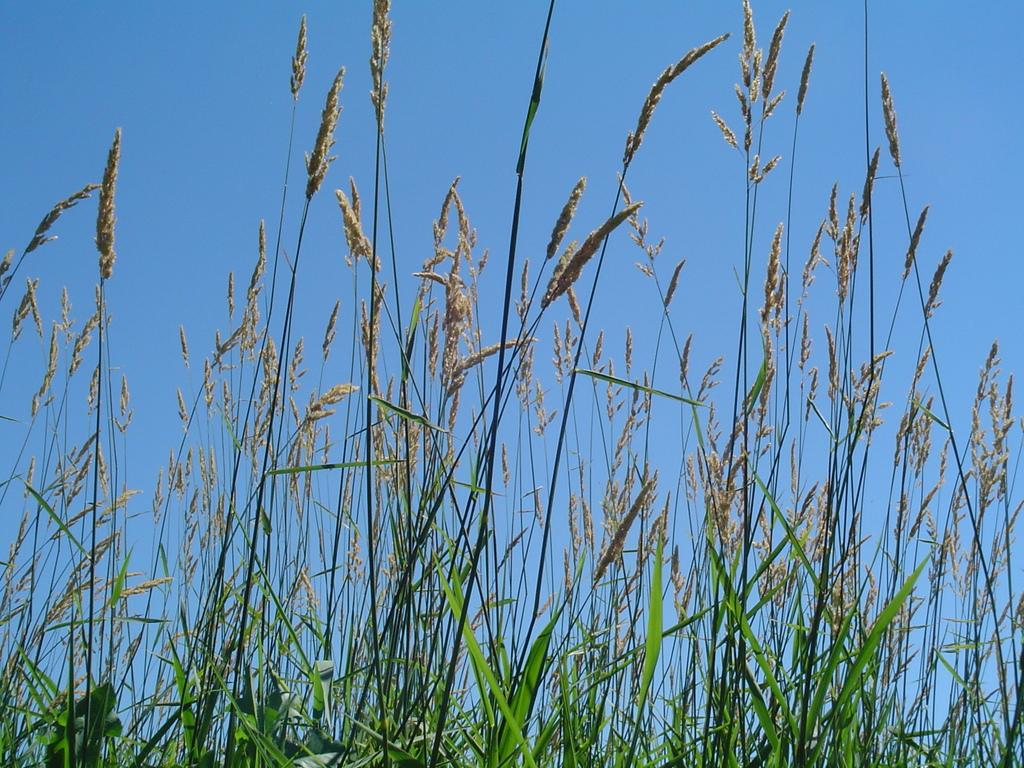Where was the image taken? The image was clicked outside. What can be seen in the foreground of the image? There are plants and green grass in the foreground of the image. What is visible in the background of the image? There is a sky visible in the background of the image. What statement does the company make about the spiders in the image? There are no spiders present in the image, and no company is mentioned, so it is not possible to answer this question. 